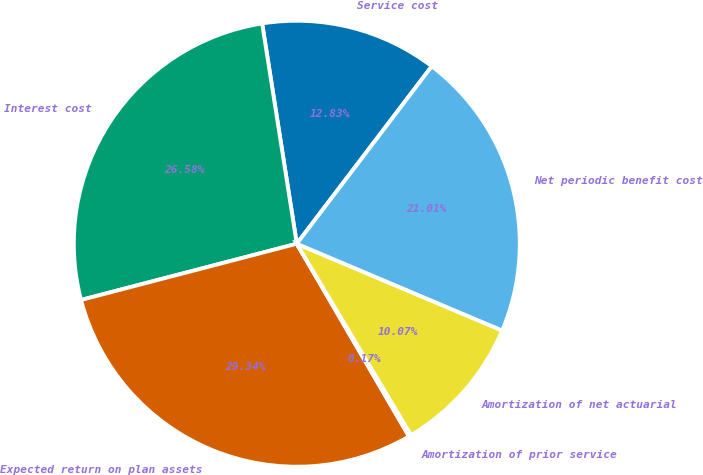Convert chart. <chart><loc_0><loc_0><loc_500><loc_500><pie_chart><fcel>Service cost<fcel>Interest cost<fcel>Expected return on plan assets<fcel>Amortization of prior service<fcel>Amortization of net actuarial<fcel>Net periodic benefit cost<nl><fcel>12.83%<fcel>26.57%<fcel>29.33%<fcel>0.17%<fcel>10.07%<fcel>21.01%<nl></chart> 